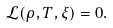<formula> <loc_0><loc_0><loc_500><loc_500>\mathcal { L } ( \rho , T , \xi ) = 0 .</formula> 